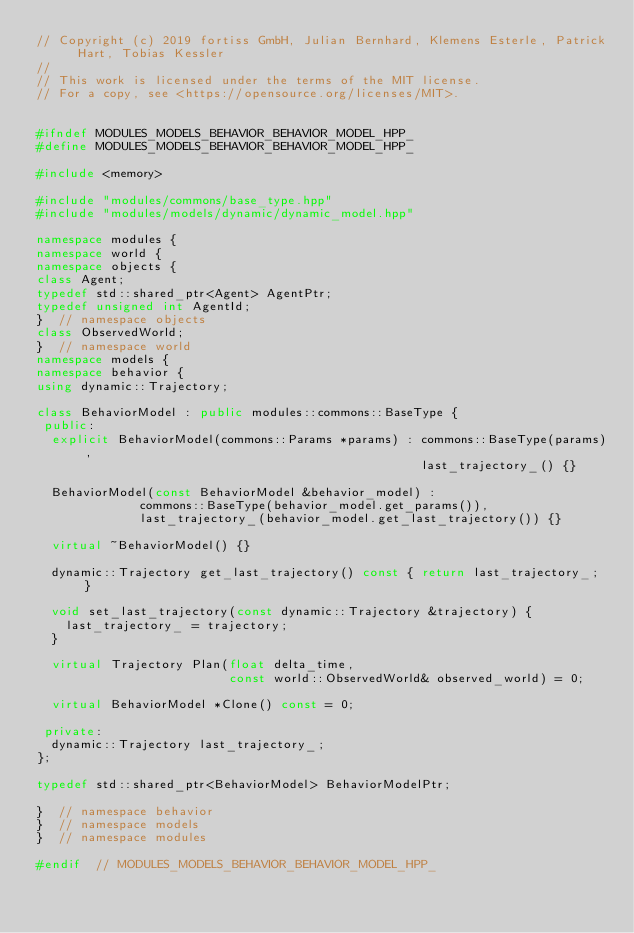<code> <loc_0><loc_0><loc_500><loc_500><_C++_>// Copyright (c) 2019 fortiss GmbH, Julian Bernhard, Klemens Esterle, Patrick Hart, Tobias Kessler
//
// This work is licensed under the terms of the MIT license.
// For a copy, see <https://opensource.org/licenses/MIT>.


#ifndef MODULES_MODELS_BEHAVIOR_BEHAVIOR_MODEL_HPP_
#define MODULES_MODELS_BEHAVIOR_BEHAVIOR_MODEL_HPP_

#include <memory>

#include "modules/commons/base_type.hpp"
#include "modules/models/dynamic/dynamic_model.hpp"

namespace modules {
namespace world {
namespace objects {
class Agent;
typedef std::shared_ptr<Agent> AgentPtr;
typedef unsigned int AgentId;
}  // namespace objects
class ObservedWorld;
}  // namespace world
namespace models {
namespace behavior {
using dynamic::Trajectory;

class BehaviorModel : public modules::commons::BaseType {
 public:
  explicit BehaviorModel(commons::Params *params) : commons::BaseType(params),
                                                    last_trajectory_() {}

  BehaviorModel(const BehaviorModel &behavior_model) : 
              commons::BaseType(behavior_model.get_params()),
              last_trajectory_(behavior_model.get_last_trajectory()) {}

  virtual ~BehaviorModel() {}

  dynamic::Trajectory get_last_trajectory() const { return last_trajectory_; }

  void set_last_trajectory(const dynamic::Trajectory &trajectory) {
    last_trajectory_ = trajectory;
  }

  virtual Trajectory Plan(float delta_time,
                          const world::ObservedWorld& observed_world) = 0;

  virtual BehaviorModel *Clone() const = 0;

 private:
  dynamic::Trajectory last_trajectory_;
};

typedef std::shared_ptr<BehaviorModel> BehaviorModelPtr;

}  // namespace behavior
}  // namespace models
}  // namespace modules

#endif  // MODULES_MODELS_BEHAVIOR_BEHAVIOR_MODEL_HPP_
</code> 